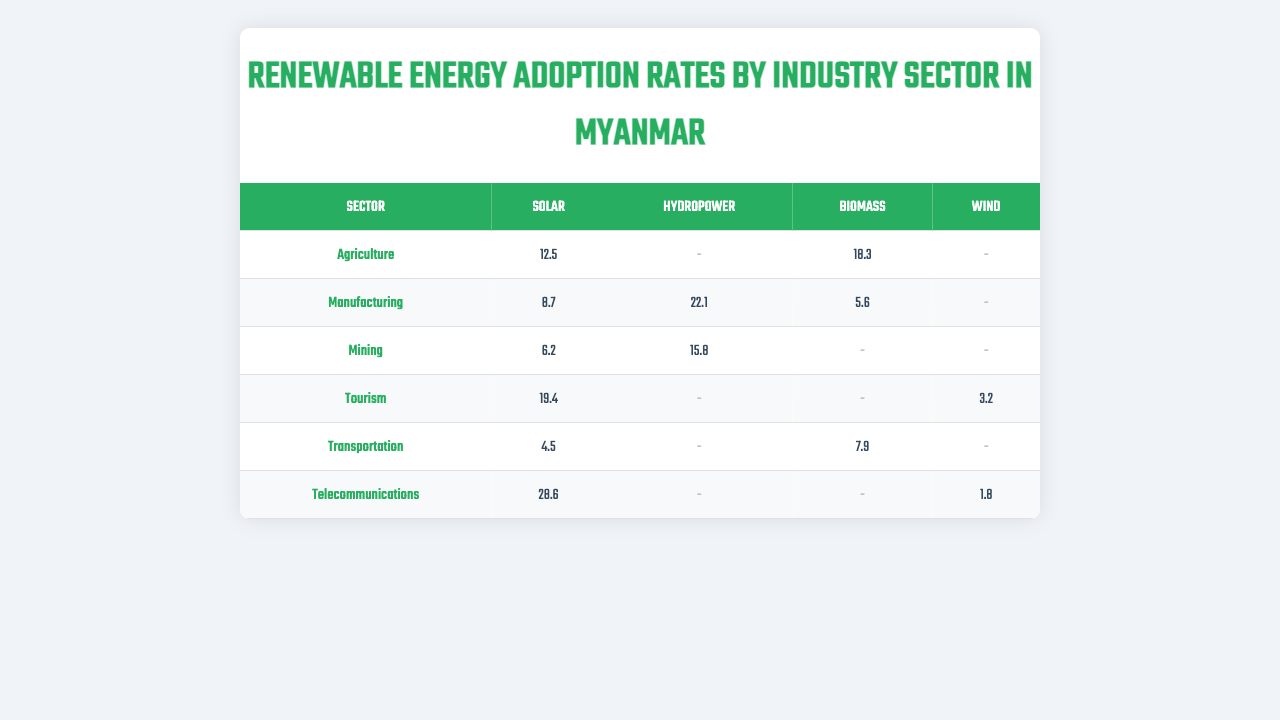What is the renewable energy adoption rate for Solar in the Agriculture sector? According to the table, the adoption rate for Solar energy in the Agriculture sector is listed as 12.5.
Answer: 12.5 Which sector has the highest adoption rate for Biomass energy? By reviewing the data, the Agriculture sector has an adoption rate of 18.3 for Biomass, which is higher than the other sectors listed.
Answer: Agriculture Is there any sector that has adopted Wind energy? The table indicates that Wind energy has been adopted in both the Tourism and Telecommunications sectors, with rates of 3.2 and 1.8 respectively.
Answer: Yes What is the average adoption rate of Solar energy across all sectors? The Solar adoption rates for each sector are: Agriculture (12.5), Manufacturing (8.7), Mining (6.2), Tourism (19.4), Transportation (4.5), Telecommunications (28.6). The total is (12.5 + 8.7 + 6.2 + 19.4 + 4.5 + 28.6) = 79.0, and there are 6 sectors, so the average is 79.0 / 6 ≈ 13.17.
Answer: Approximately 13.17 Which energy source has the lowest adoption rate in the Transportation sector? In the Transportation sector, the adoption rates for Solar and Biomass are 4.5 and 7.9 respectively; therefore, Solar has a lower adoption rate.
Answer: Solar If we combine the Hydropower adoption rates of the Manufacturing and Mining sectors, what would be the total? The Hydropower adoption rate for Manufacturing is 22.1 and for Mining is 15.8. Adding these gives 22.1 + 15.8 = 37.9.
Answer: 37.9 Which sector has the least variety in energy sources adopted? The Transportation sector has only two energy sources listed (Solar and Biomass), while others have more. Thus, it has the least variety.
Answer: Transportation How do the Solar adoption rates in Telecommunications and Tourism compare? The Solar adoption rate in Telecommunications is 28.6 while in Tourism it is 19.4. Since 28.6 is greater than 19.4, Telecommunications has a higher rate.
Answer: Telecommunications has a higher rate Is the Biomas energy adoption rate higher in Mining compared to Agricultural sector? The Biomass adoption rate in Agriculture is 18.3 and in Mining it is not listed, which indicates it's 0. Therefore, Agriculture has a higher rate.
Answer: No 